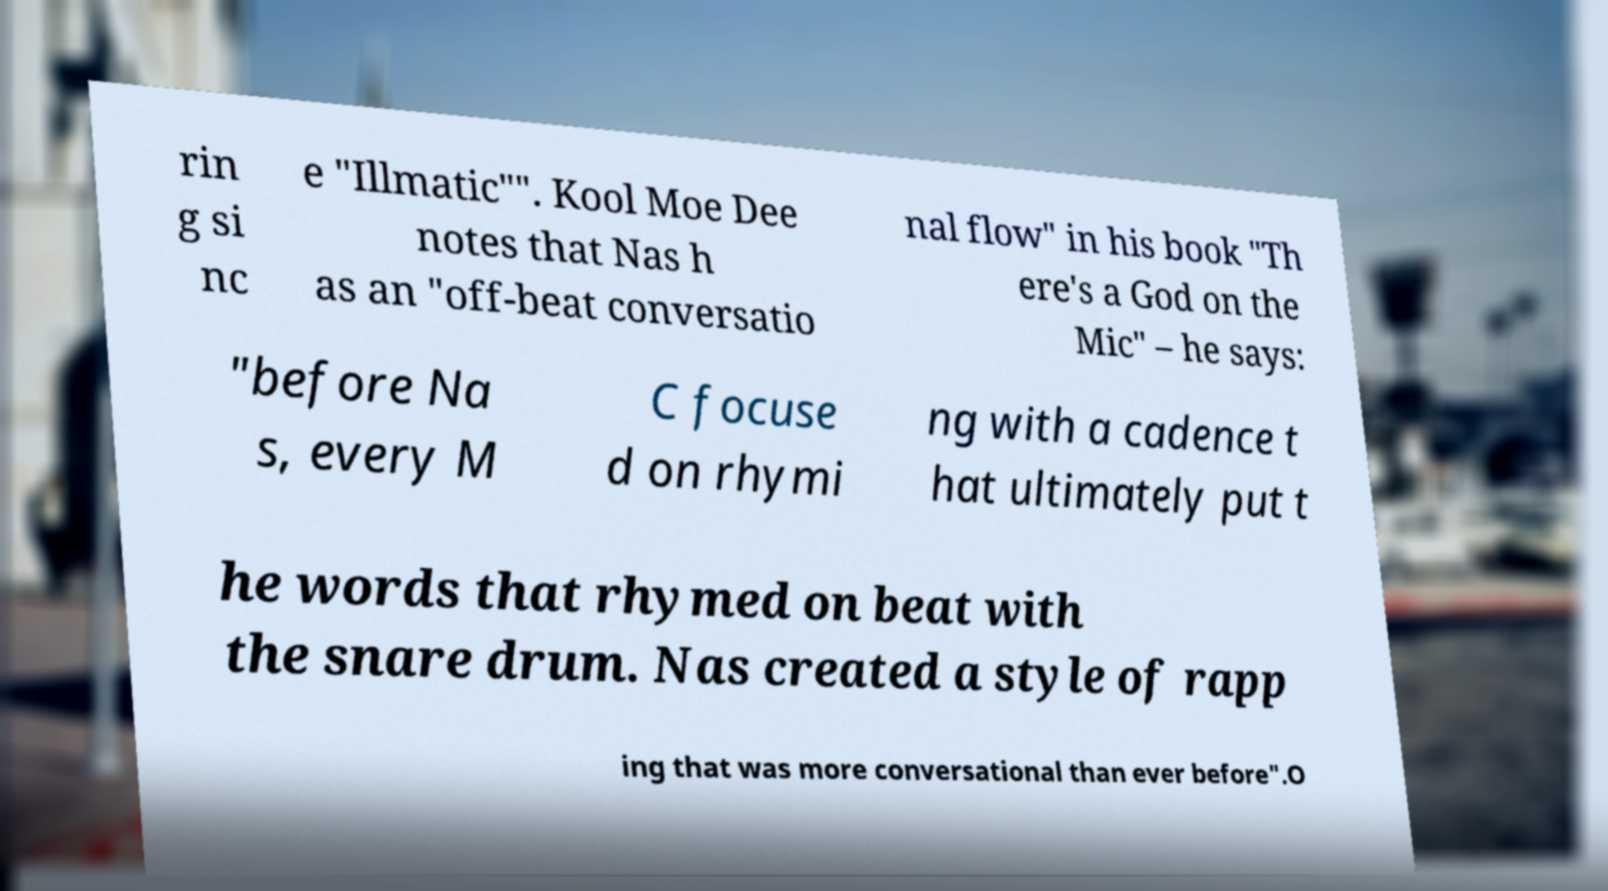There's text embedded in this image that I need extracted. Can you transcribe it verbatim? rin g si nc e "Illmatic"". Kool Moe Dee notes that Nas h as an "off-beat conversatio nal flow" in his book "Th ere's a God on the Mic" – he says: "before Na s, every M C focuse d on rhymi ng with a cadence t hat ultimately put t he words that rhymed on beat with the snare drum. Nas created a style of rapp ing that was more conversational than ever before".O 